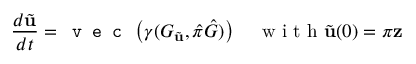<formula> <loc_0><loc_0><loc_500><loc_500>\frac { d \tilde { u } } { d t } = v e c \left ( \gamma ( G _ { \tilde { u } } , \hat { \pi } \hat { G } ) \right ) \quad w i t h \tilde { u } ( 0 ) = \pi z</formula> 